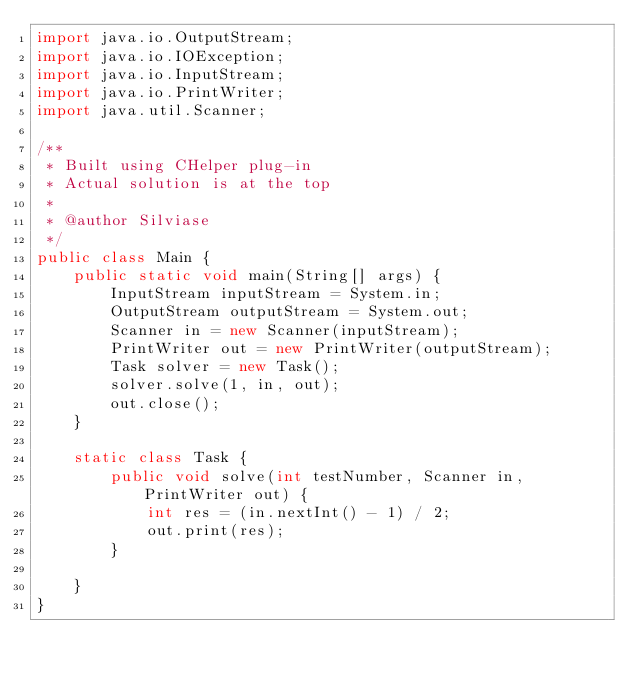Convert code to text. <code><loc_0><loc_0><loc_500><loc_500><_Java_>import java.io.OutputStream;
import java.io.IOException;
import java.io.InputStream;
import java.io.PrintWriter;
import java.util.Scanner;

/**
 * Built using CHelper plug-in
 * Actual solution is at the top
 *
 * @author Silviase
 */
public class Main {
    public static void main(String[] args) {
        InputStream inputStream = System.in;
        OutputStream outputStream = System.out;
        Scanner in = new Scanner(inputStream);
        PrintWriter out = new PrintWriter(outputStream);
        Task solver = new Task();
        solver.solve(1, in, out);
        out.close();
    }

    static class Task {
        public void solve(int testNumber, Scanner in, PrintWriter out) {
            int res = (in.nextInt() - 1) / 2;
            out.print(res);
        }

    }
}

</code> 